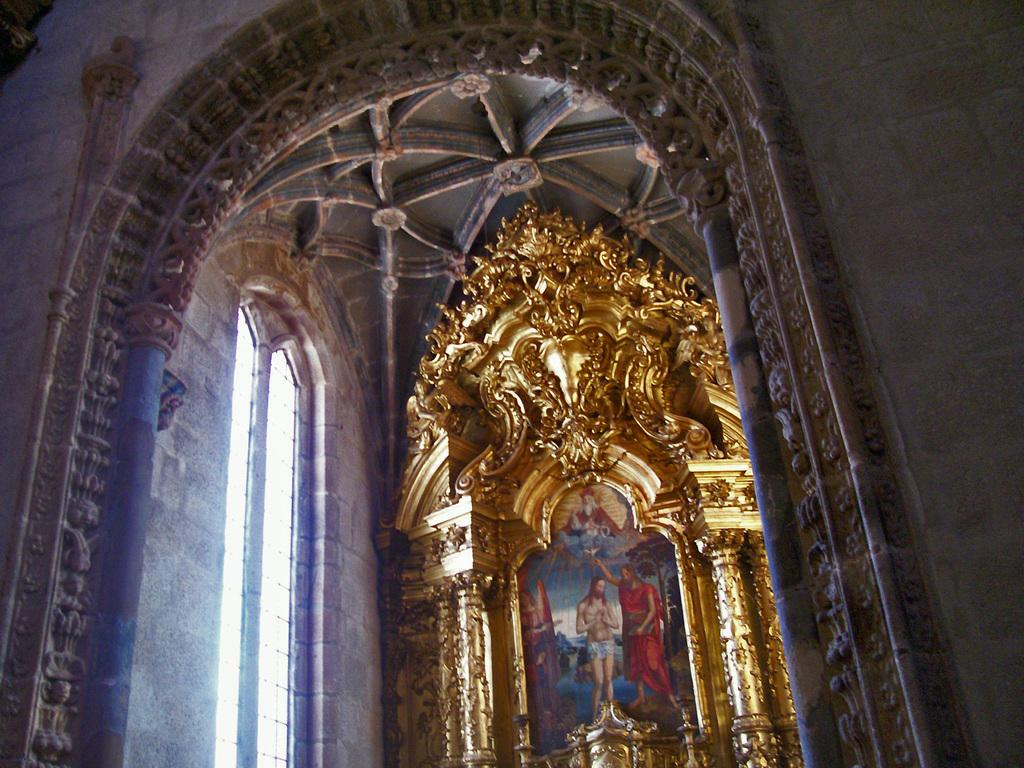What type of setting is depicted in the image? The image shows an interior view of a building. What architectural feature can be seen in the building? There is an arch in the building. What type of decorative item is present in the building? There is a decorative item with pillars in the building. What type of artwork can be seen in the building? There is a painting in the building. What type of grain is being stored in the building in the image? There is no indication of grain or storage in the image; it shows an interior view of a building with an arch, a decorative item with pillars, and a painting. Can you see a rake being used to clean the floor in the image? There is no rake visible in the image; it shows an interior view of a building with an arch, a decorative item with pillars, and a painting. 